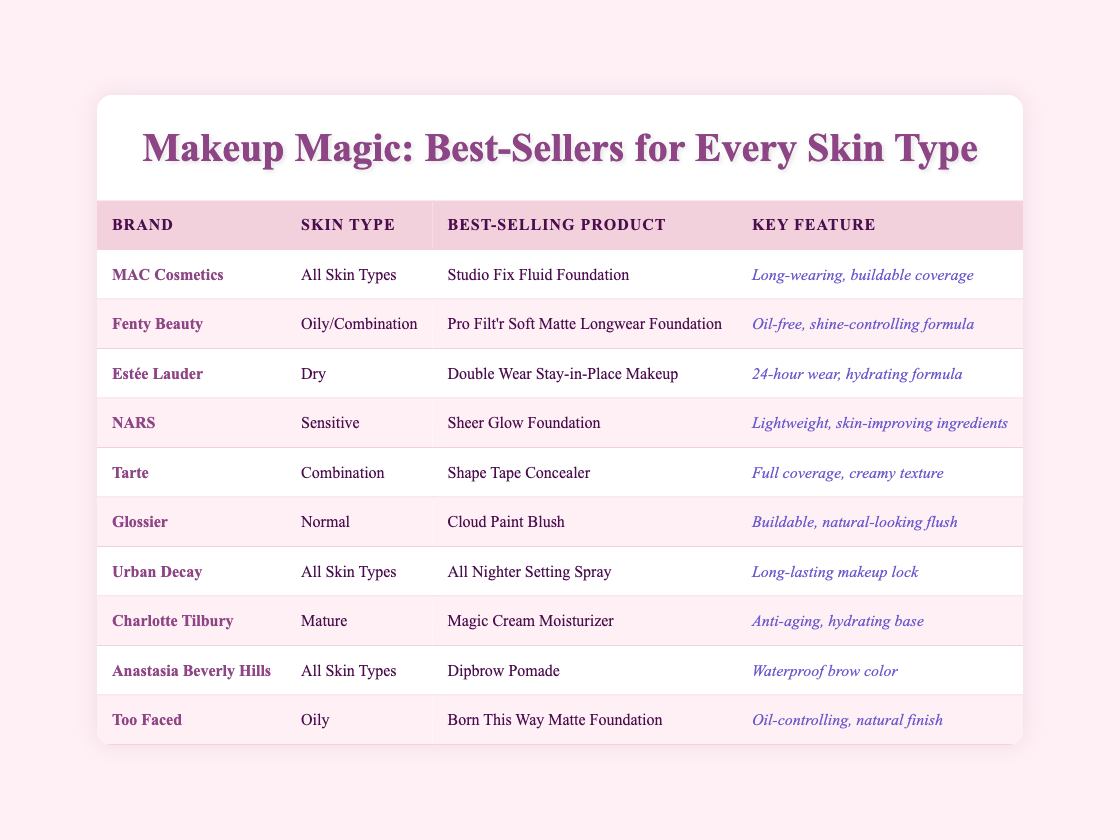What is the best-selling product for Fenty Beauty? According to the table, the best-selling product for Fenty Beauty is the Pro Filt'r Soft Matte Longwear Foundation.
Answer: Pro Filt'r Soft Matte Longwear Foundation Which brand offers a product specifically for dry skin? Looking at the table, Estée Lauder is the brand that offers a product for dry skin, its best-selling product is Double Wear Stay-in-Place Makeup.
Answer: Estée Lauder Are there any brands that cater to all skin types? Yes, both MAC Cosmetics and Urban Decay are brands that cater to all skin types according to the table.
Answer: Yes What is the key feature of the Shape Tape Concealer by Tarte? The table states that the Shape Tape Concealer by Tarte has a key feature of full coverage and a creamy texture.
Answer: Full coverage, creamy texture Which best-selling product has an anti-aging feature and what brand is it associated with? The table shows that Charlotte Tilbury's Magic Cream Moisturizer has an anti-aging feature, making it the associated best-selling product.
Answer: Magic Cream Moisturizer What is the total number of brands listed that cater to oily skin types? By examining the table, Fenty Beauty and Too Faced are both brands listed for oily skin types, totaling two brands.
Answer: 2 Is the Sheer Glow Foundation designed for sensitive skin? Yes, according to the table, the Sheer Glow Foundation by NARS is indeed designed for sensitive skin.
Answer: Yes What percentage of the listed brands have products for normal skin types? From the table, there are 10 brands in total, and only 1 brand, Glossier, offers a product for normal skin types. Therefore, the percentage is (1/10) * 100 = 10%.
Answer: 10% Which brand has a key feature describing its product as oil-free and shine-controlling? According to the table, the brand Fenty Beauty describes its best-selling product, the Pro Filt'r Soft Matte Longwear Foundation, as oil-free and shine-controlling.
Answer: Fenty Beauty 